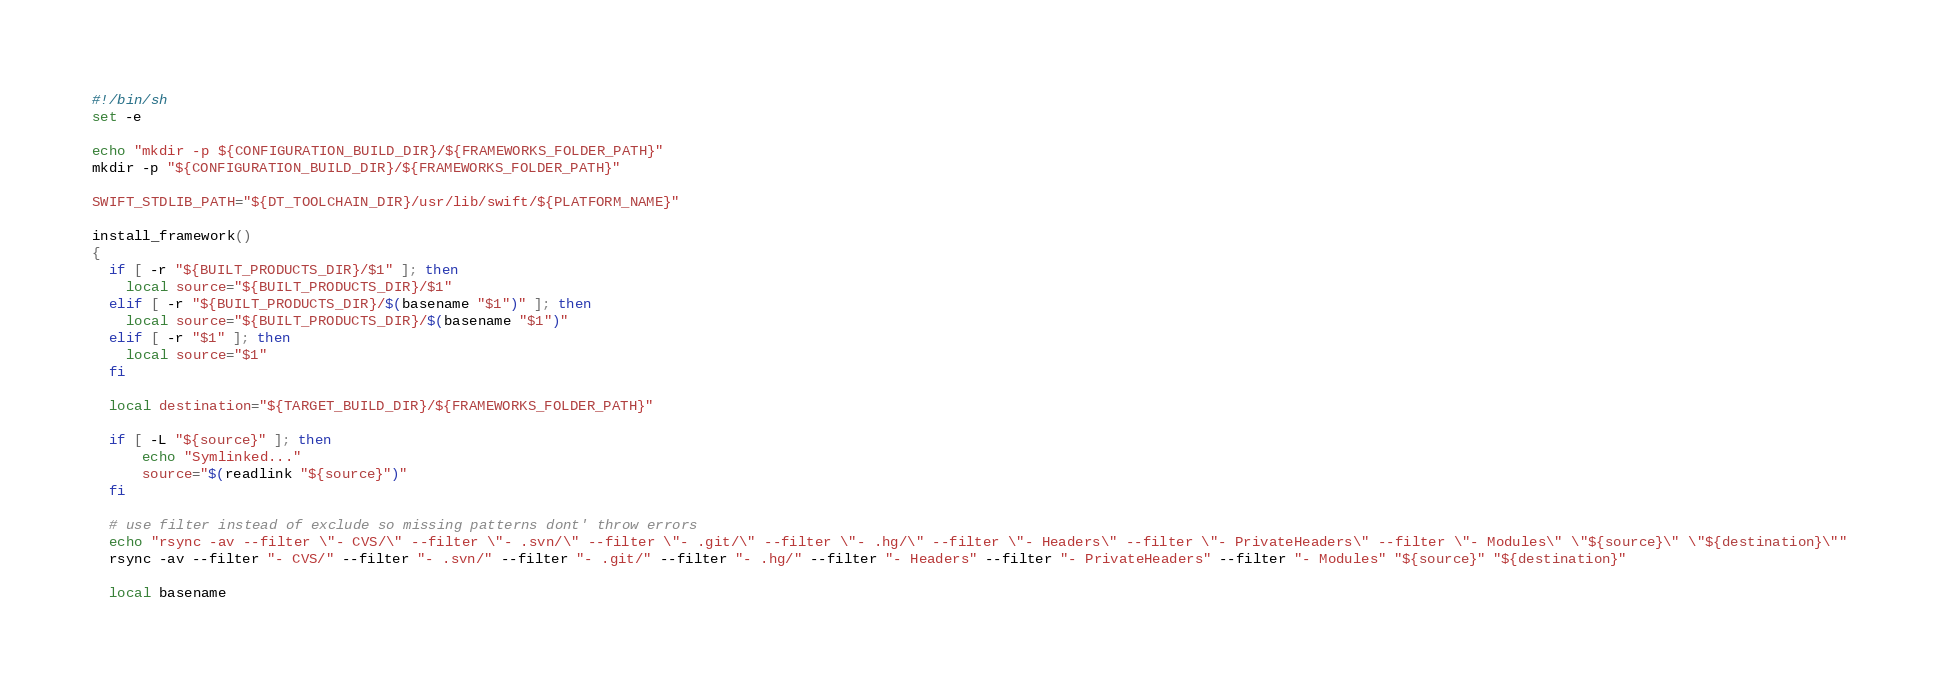Convert code to text. <code><loc_0><loc_0><loc_500><loc_500><_Bash_>#!/bin/sh
set -e

echo "mkdir -p ${CONFIGURATION_BUILD_DIR}/${FRAMEWORKS_FOLDER_PATH}"
mkdir -p "${CONFIGURATION_BUILD_DIR}/${FRAMEWORKS_FOLDER_PATH}"

SWIFT_STDLIB_PATH="${DT_TOOLCHAIN_DIR}/usr/lib/swift/${PLATFORM_NAME}"

install_framework()
{
  if [ -r "${BUILT_PRODUCTS_DIR}/$1" ]; then
    local source="${BUILT_PRODUCTS_DIR}/$1"
  elif [ -r "${BUILT_PRODUCTS_DIR}/$(basename "$1")" ]; then
    local source="${BUILT_PRODUCTS_DIR}/$(basename "$1")"
  elif [ -r "$1" ]; then
    local source="$1"
  fi

  local destination="${TARGET_BUILD_DIR}/${FRAMEWORKS_FOLDER_PATH}"

  if [ -L "${source}" ]; then
      echo "Symlinked..."
      source="$(readlink "${source}")"
  fi

  # use filter instead of exclude so missing patterns dont' throw errors
  echo "rsync -av --filter \"- CVS/\" --filter \"- .svn/\" --filter \"- .git/\" --filter \"- .hg/\" --filter \"- Headers\" --filter \"- PrivateHeaders\" --filter \"- Modules\" \"${source}\" \"${destination}\""
  rsync -av --filter "- CVS/" --filter "- .svn/" --filter "- .git/" --filter "- .hg/" --filter "- Headers" --filter "- PrivateHeaders" --filter "- Modules" "${source}" "${destination}"

  local basename</code> 